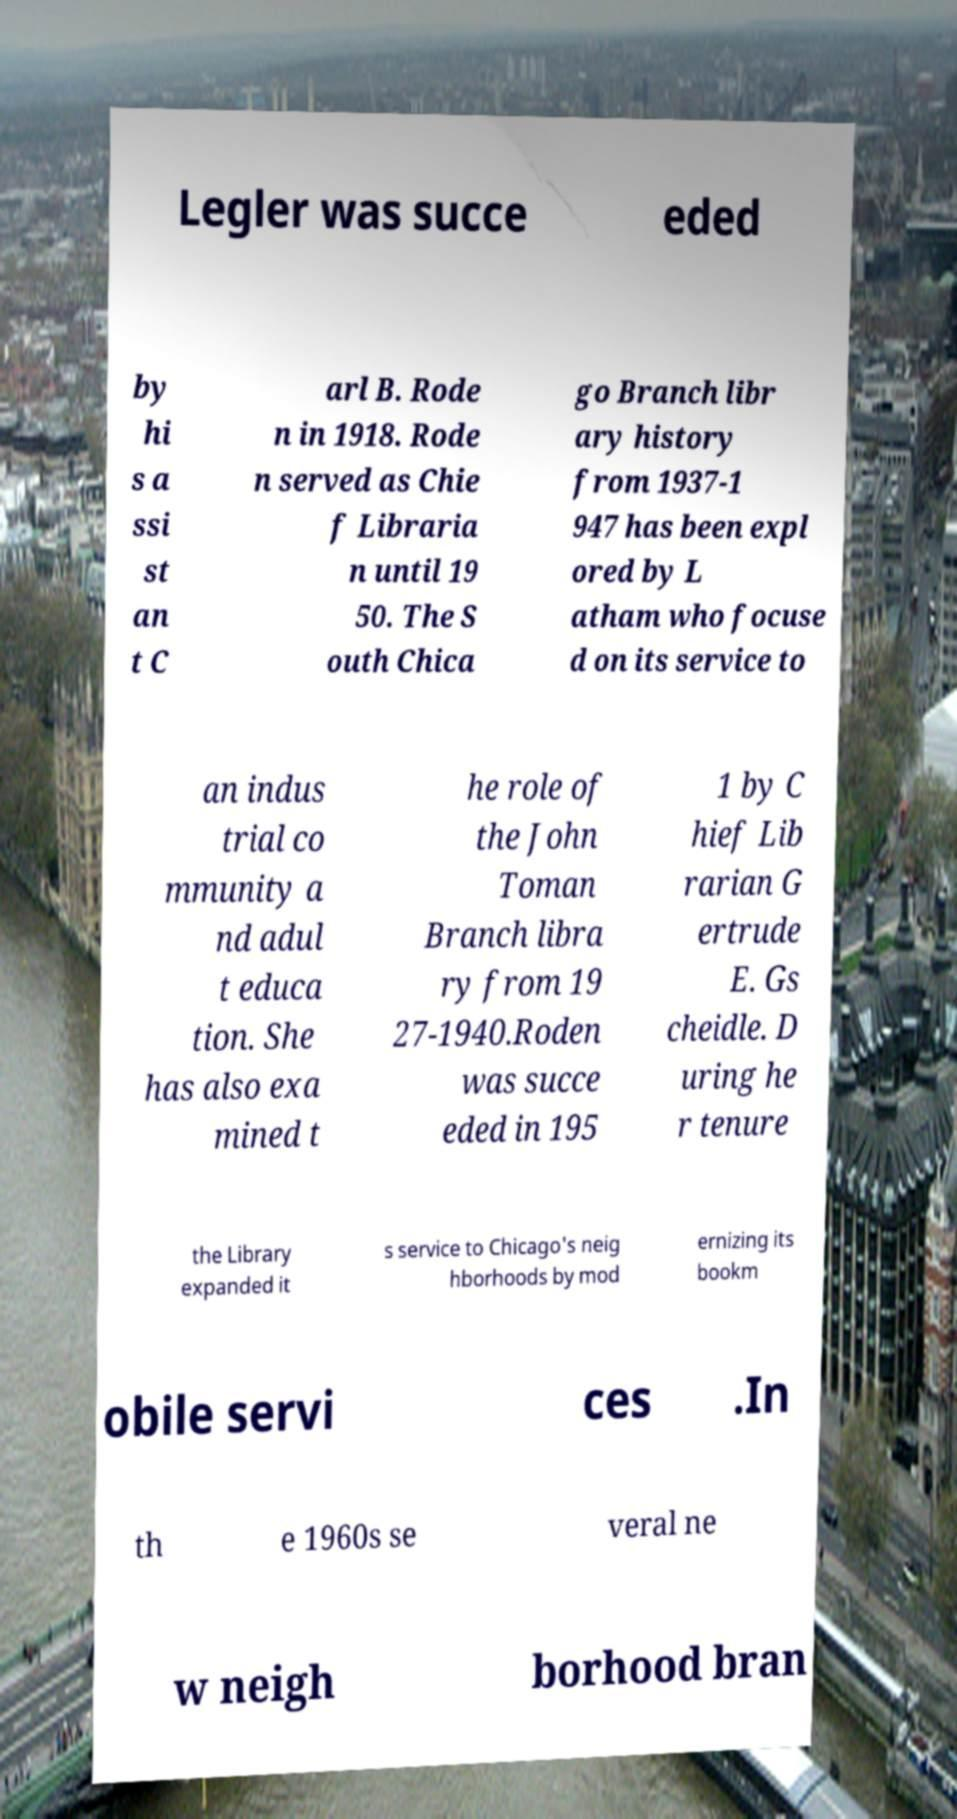Could you assist in decoding the text presented in this image and type it out clearly? Legler was succe eded by hi s a ssi st an t C arl B. Rode n in 1918. Rode n served as Chie f Libraria n until 19 50. The S outh Chica go Branch libr ary history from 1937-1 947 has been expl ored by L atham who focuse d on its service to an indus trial co mmunity a nd adul t educa tion. She has also exa mined t he role of the John Toman Branch libra ry from 19 27-1940.Roden was succe eded in 195 1 by C hief Lib rarian G ertrude E. Gs cheidle. D uring he r tenure the Library expanded it s service to Chicago's neig hborhoods by mod ernizing its bookm obile servi ces .In th e 1960s se veral ne w neigh borhood bran 